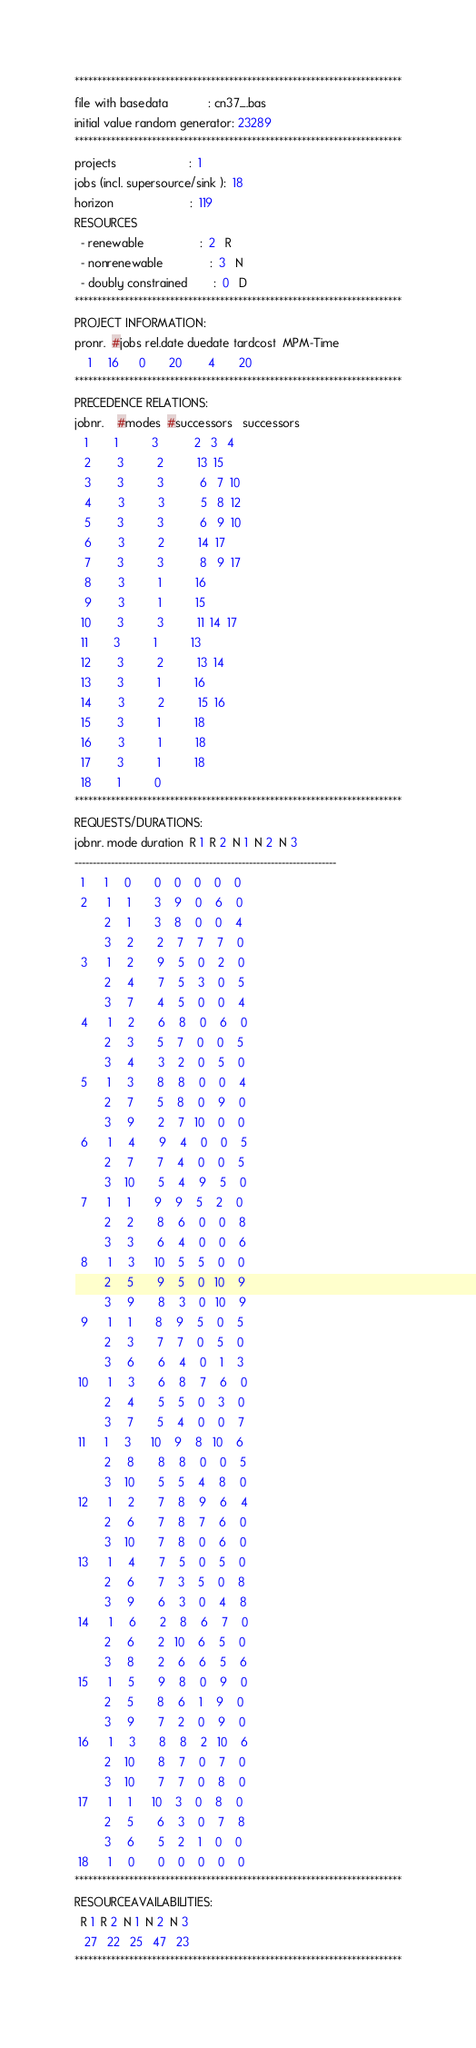Convert code to text. <code><loc_0><loc_0><loc_500><loc_500><_ObjectiveC_>************************************************************************
file with basedata            : cn37_.bas
initial value random generator: 23289
************************************************************************
projects                      :  1
jobs (incl. supersource/sink ):  18
horizon                       :  119
RESOURCES
  - renewable                 :  2   R
  - nonrenewable              :  3   N
  - doubly constrained        :  0   D
************************************************************************
PROJECT INFORMATION:
pronr.  #jobs rel.date duedate tardcost  MPM-Time
    1     16      0       20        4       20
************************************************************************
PRECEDENCE RELATIONS:
jobnr.    #modes  #successors   successors
   1        1          3           2   3   4
   2        3          2          13  15
   3        3          3           6   7  10
   4        3          3           5   8  12
   5        3          3           6   9  10
   6        3          2          14  17
   7        3          3           8   9  17
   8        3          1          16
   9        3          1          15
  10        3          3          11  14  17
  11        3          1          13
  12        3          2          13  14
  13        3          1          16
  14        3          2          15  16
  15        3          1          18
  16        3          1          18
  17        3          1          18
  18        1          0        
************************************************************************
REQUESTS/DURATIONS:
jobnr. mode duration  R 1  R 2  N 1  N 2  N 3
------------------------------------------------------------------------
  1      1     0       0    0    0    0    0
  2      1     1       3    9    0    6    0
         2     1       3    8    0    0    4
         3     2       2    7    7    7    0
  3      1     2       9    5    0    2    0
         2     4       7    5    3    0    5
         3     7       4    5    0    0    4
  4      1     2       6    8    0    6    0
         2     3       5    7    0    0    5
         3     4       3    2    0    5    0
  5      1     3       8    8    0    0    4
         2     7       5    8    0    9    0
         3     9       2    7   10    0    0
  6      1     4       9    4    0    0    5
         2     7       7    4    0    0    5
         3    10       5    4    9    5    0
  7      1     1       9    9    5    2    0
         2     2       8    6    0    0    8
         3     3       6    4    0    0    6
  8      1     3      10    5    5    0    0
         2     5       9    5    0   10    9
         3     9       8    3    0   10    9
  9      1     1       8    9    5    0    5
         2     3       7    7    0    5    0
         3     6       6    4    0    1    3
 10      1     3       6    8    7    6    0
         2     4       5    5    0    3    0
         3     7       5    4    0    0    7
 11      1     3      10    9    8   10    6
         2     8       8    8    0    0    5
         3    10       5    5    4    8    0
 12      1     2       7    8    9    6    4
         2     6       7    8    7    6    0
         3    10       7    8    0    6    0
 13      1     4       7    5    0    5    0
         2     6       7    3    5    0    8
         3     9       6    3    0    4    8
 14      1     6       2    8    6    7    0
         2     6       2   10    6    5    0
         3     8       2    6    6    5    6
 15      1     5       9    8    0    9    0
         2     5       8    6    1    9    0
         3     9       7    2    0    9    0
 16      1     3       8    8    2   10    6
         2    10       8    7    0    7    0
         3    10       7    7    0    8    0
 17      1     1      10    3    0    8    0
         2     5       6    3    0    7    8
         3     6       5    2    1    0    0
 18      1     0       0    0    0    0    0
************************************************************************
RESOURCEAVAILABILITIES:
  R 1  R 2  N 1  N 2  N 3
   27   22   25   47   23
************************************************************************
</code> 